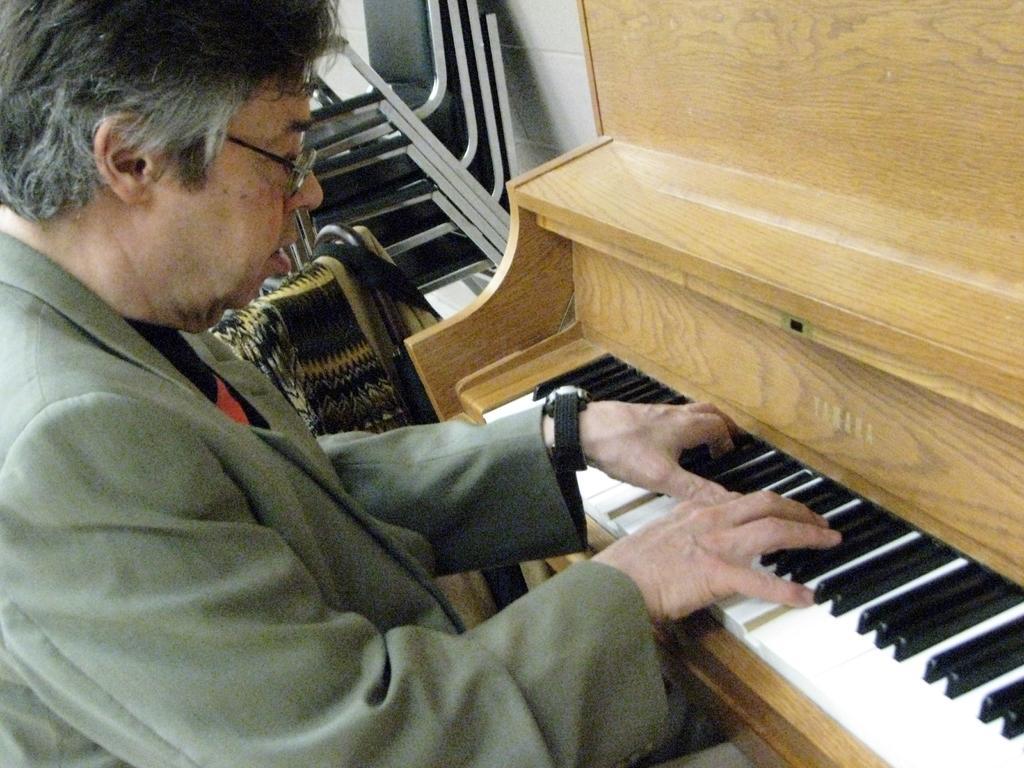How would you summarize this image in a sentence or two? In this image there is a person wearing suit playing a musical instrument. 